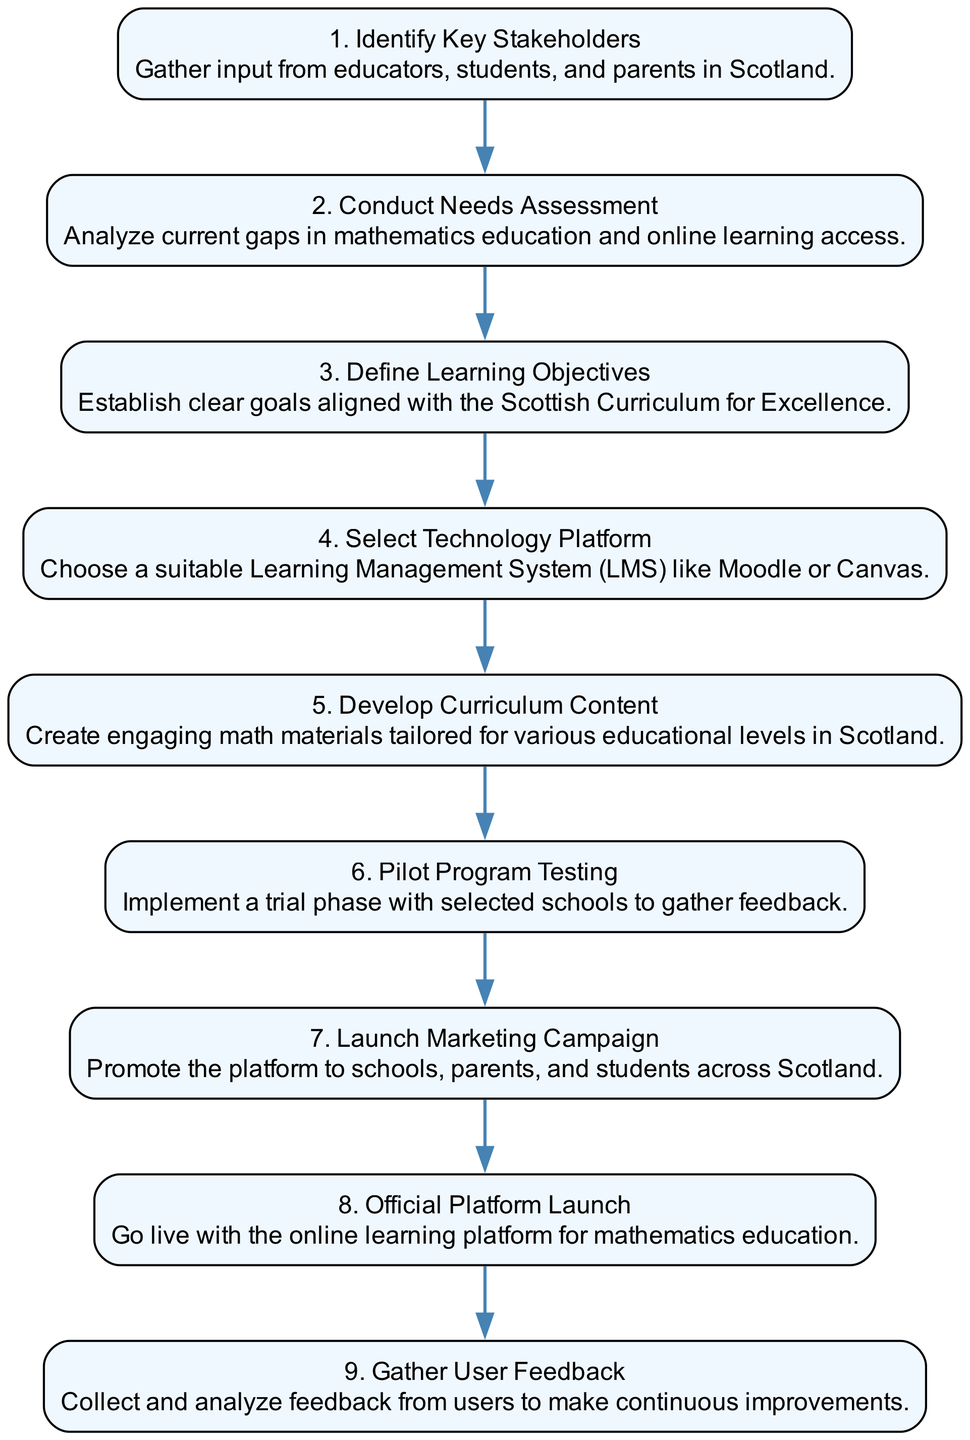What is the first step in the implementation process? The first step is represented by the first node in the sequence diagram, which states "Identify Key Stakeholders." This node introduces the implementation process, indicating the initiating action.
Answer: Identify Key Stakeholders How many total steps are involved in the implementation process? Counting the nodes in the sequence diagram reveals there are a total of nine distinct steps listed. Each step is represented by a unique node.
Answer: Nine What step follows "Pilot Program Testing"? To find this, one would look at the edge directed from "Pilot Program Testing" to the next node, which is "Launch Marketing Campaign." This sequential flow indicates the next action to take.
Answer: Launch Marketing Campaign Which step focuses on technology selection? Examining the nodes, the step that addresses technology selection is labeled "Select Technology Platform." This clearly identifies the focus on choosing a suitable LMS.
Answer: Select Technology Platform What step involves gathering feedback from users? The diagram shows that "Gather User Feedback" is the step specifically related to collecting and analyzing user experiences to improve the platform.
Answer: Gather User Feedback How does "Conduct Needs Assessment" relate to the overall process? This step is crucial as it follows the identification of stakeholders and precedes the definition of learning objectives. It highlights an analytical phase to identify educational gaps.
Answer: It helps identify gaps What is the sequence of steps from content development to feedback gathering? Analyzing the diagram, the sequence begins with "Develop Curriculum Content," followed by "Pilot Program Testing," then "Official Platform Launch," and finally "Gather User Feedback." This shows a logical flow from development to evaluation.
Answer: Develop Curriculum Content, Pilot Program Testing, Official Platform Launch, Gather User Feedback Which step has a primary focus on marketing? The step that emphasizes marketing is "Launch Marketing Campaign." It is dedicated to promoting the platform to the intended users.
Answer: Launch Marketing Campaign What step ensures the platform meets academic standards? The description for "Define Learning Objectives" specifies that the goals established are aligned with the Scottish Curriculum for Excellence, ensuring educational framework adherence.
Answer: Define Learning Objectives 